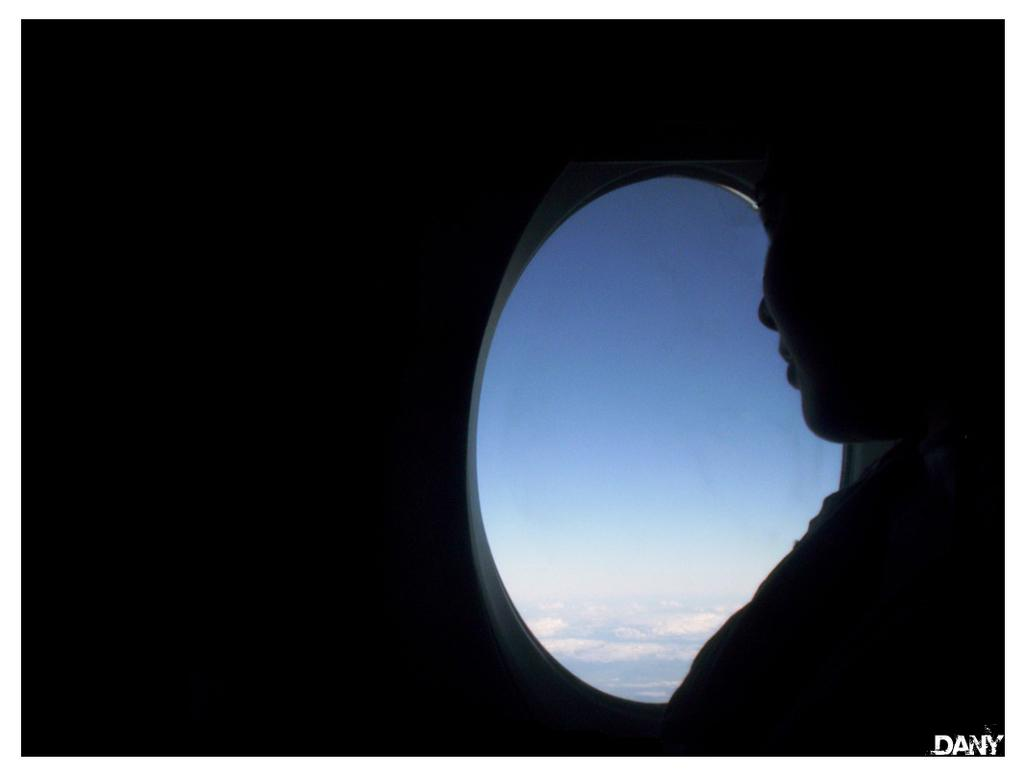What is the person in the image doing? There is a person sitting inside an airplane in the image. What can be seen outside the airplane? The sky is visible in the image. What is the condition of the sky? There are clouds in the sky in the image. What information is provided at the bottom of the image? There is text at the bottom of the image. How does the person in the image measure the distance between the clouds? There is no indication in the image that the person is measuring anything, let alone the distance between clouds. 